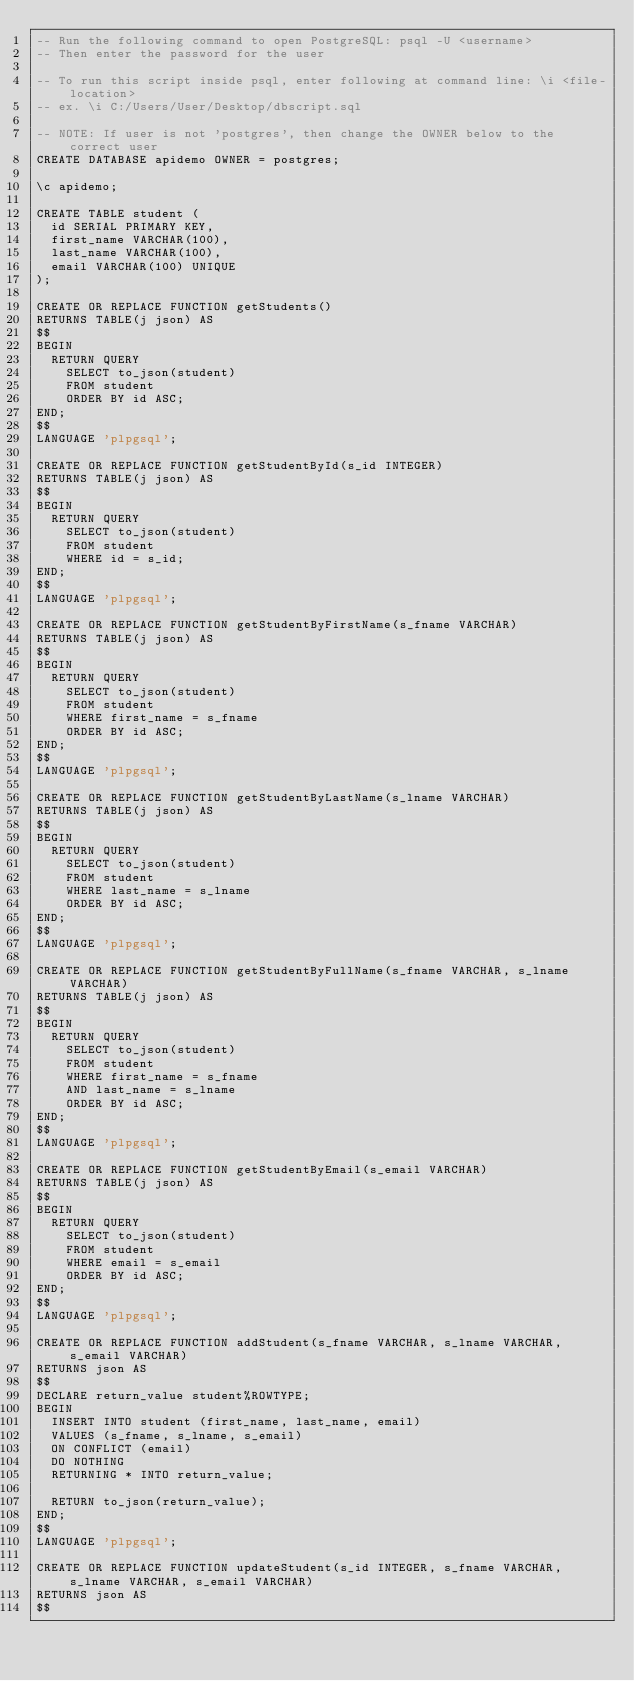<code> <loc_0><loc_0><loc_500><loc_500><_SQL_>-- Run the following command to open PostgreSQL: psql -U <username>
-- Then enter the password for the user

-- To run this script inside psql, enter following at command line: \i <file-location>
-- ex. \i C:/Users/User/Desktop/dbscript.sql

-- NOTE: If user is not 'postgres', then change the OWNER below to the correct user
CREATE DATABASE apidemo OWNER = postgres;

\c apidemo;

CREATE TABLE student (
	id SERIAL PRIMARY KEY,
	first_name VARCHAR(100),
	last_name VARCHAR(100),
	email VARCHAR(100) UNIQUE
);

CREATE OR REPLACE FUNCTION getStudents()
RETURNS TABLE(j json) AS
$$
BEGIN
	RETURN QUERY
		SELECT to_json(student) 
		FROM student
		ORDER BY id ASC;
END;
$$
LANGUAGE 'plpgsql';

CREATE OR REPLACE FUNCTION getStudentById(s_id INTEGER)
RETURNS TABLE(j json) AS
$$
BEGIN
	RETURN QUERY
		SELECT to_json(student)
		FROM student
		WHERE id = s_id;
END;
$$
LANGUAGE 'plpgsql';

CREATE OR REPLACE FUNCTION getStudentByFirstName(s_fname VARCHAR)
RETURNS TABLE(j json) AS
$$
BEGIN
	RETURN QUERY
		SELECT to_json(student) 
		FROM student
		WHERE first_name = s_fname
		ORDER BY id ASC;
END;
$$
LANGUAGE 'plpgsql';

CREATE OR REPLACE FUNCTION getStudentByLastName(s_lname VARCHAR)
RETURNS TABLE(j json) AS
$$
BEGIN
	RETURN QUERY
		SELECT to_json(student) 
		FROM student
		WHERE last_name = s_lname
		ORDER BY id ASC;
END;
$$
LANGUAGE 'plpgsql';

CREATE OR REPLACE FUNCTION getStudentByFullName(s_fname VARCHAR, s_lname VARCHAR)
RETURNS TABLE(j json) AS
$$
BEGIN
	RETURN QUERY
		SELECT to_json(student) 
		FROM student
		WHERE first_name = s_fname
		AND last_name = s_lname
		ORDER BY id ASC;
END;
$$
LANGUAGE 'plpgsql';

CREATE OR REPLACE FUNCTION getStudentByEmail(s_email VARCHAR)
RETURNS TABLE(j json) AS
$$
BEGIN
	RETURN QUERY
		SELECT to_json(student) 
		FROM student
		WHERE email = s_email
		ORDER BY id ASC;
END;
$$
LANGUAGE 'plpgsql';

CREATE OR REPLACE FUNCTION addStudent(s_fname VARCHAR, s_lname VARCHAR, s_email VARCHAR)
RETURNS json AS
$$
DECLARE return_value student%ROWTYPE;
BEGIN
	INSERT INTO student (first_name, last_name, email)
	VALUES (s_fname, s_lname, s_email)
	ON CONFLICT (email)
	DO NOTHING
	RETURNING * INTO return_value;

	RETURN to_json(return_value);
END;
$$
LANGUAGE 'plpgsql';

CREATE OR REPLACE FUNCTION updateStudent(s_id INTEGER, s_fname VARCHAR, s_lname VARCHAR, s_email VARCHAR)
RETURNS json AS
$$</code> 